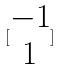Convert formula to latex. <formula><loc_0><loc_0><loc_500><loc_500>[ \begin{matrix} - 1 \\ 1 \end{matrix} ]</formula> 